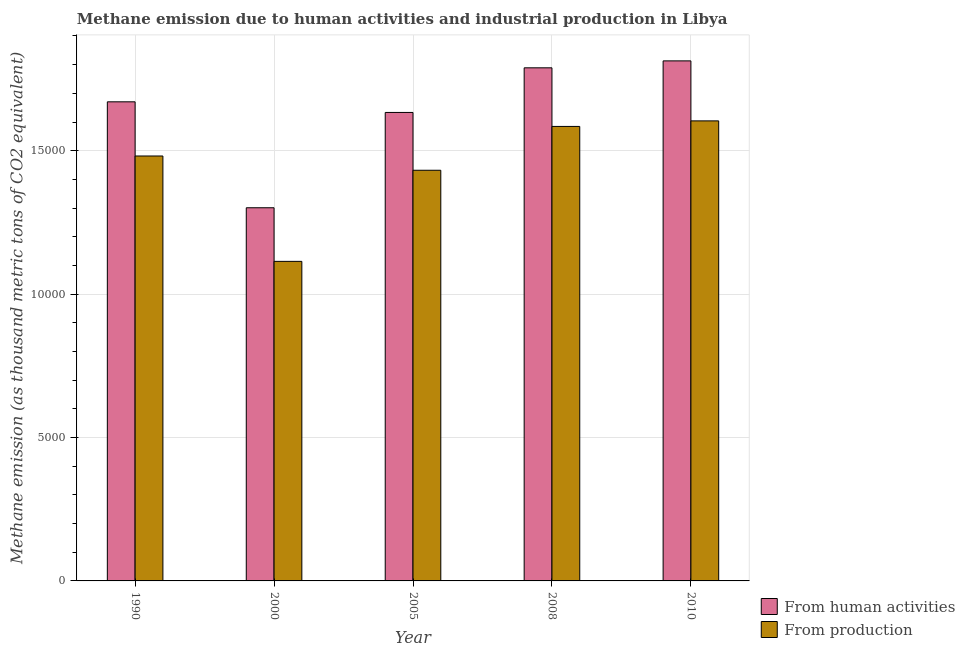Are the number of bars per tick equal to the number of legend labels?
Provide a short and direct response. Yes. How many bars are there on the 5th tick from the left?
Provide a succinct answer. 2. In how many cases, is the number of bars for a given year not equal to the number of legend labels?
Provide a succinct answer. 0. What is the amount of emissions generated from industries in 2005?
Your response must be concise. 1.43e+04. Across all years, what is the maximum amount of emissions generated from industries?
Your answer should be compact. 1.60e+04. Across all years, what is the minimum amount of emissions from human activities?
Offer a very short reply. 1.30e+04. What is the total amount of emissions from human activities in the graph?
Your answer should be compact. 8.21e+04. What is the difference between the amount of emissions generated from industries in 2005 and that in 2008?
Your answer should be compact. -1527.9. What is the difference between the amount of emissions generated from industries in 1990 and the amount of emissions from human activities in 2005?
Your answer should be compact. 497.1. What is the average amount of emissions generated from industries per year?
Offer a terse response. 1.44e+04. What is the ratio of the amount of emissions generated from industries in 2000 to that in 2008?
Provide a succinct answer. 0.7. Is the amount of emissions generated from industries in 1990 less than that in 2010?
Ensure brevity in your answer.  Yes. What is the difference between the highest and the second highest amount of emissions from human activities?
Offer a very short reply. 242.2. What is the difference between the highest and the lowest amount of emissions from human activities?
Ensure brevity in your answer.  5121.1. Is the sum of the amount of emissions from human activities in 2000 and 2008 greater than the maximum amount of emissions generated from industries across all years?
Keep it short and to the point. Yes. What does the 1st bar from the left in 2005 represents?
Your answer should be compact. From human activities. What does the 1st bar from the right in 2010 represents?
Offer a very short reply. From production. Does the graph contain any zero values?
Your answer should be very brief. No. Does the graph contain grids?
Provide a succinct answer. Yes. Where does the legend appear in the graph?
Keep it short and to the point. Bottom right. What is the title of the graph?
Make the answer very short. Methane emission due to human activities and industrial production in Libya. What is the label or title of the X-axis?
Your response must be concise. Year. What is the label or title of the Y-axis?
Make the answer very short. Methane emission (as thousand metric tons of CO2 equivalent). What is the Methane emission (as thousand metric tons of CO2 equivalent) of From human activities in 1990?
Your answer should be very brief. 1.67e+04. What is the Methane emission (as thousand metric tons of CO2 equivalent) in From production in 1990?
Give a very brief answer. 1.48e+04. What is the Methane emission (as thousand metric tons of CO2 equivalent) in From human activities in 2000?
Your answer should be compact. 1.30e+04. What is the Methane emission (as thousand metric tons of CO2 equivalent) in From production in 2000?
Offer a terse response. 1.11e+04. What is the Methane emission (as thousand metric tons of CO2 equivalent) in From human activities in 2005?
Offer a terse response. 1.63e+04. What is the Methane emission (as thousand metric tons of CO2 equivalent) of From production in 2005?
Offer a very short reply. 1.43e+04. What is the Methane emission (as thousand metric tons of CO2 equivalent) in From human activities in 2008?
Your response must be concise. 1.79e+04. What is the Methane emission (as thousand metric tons of CO2 equivalent) in From production in 2008?
Offer a terse response. 1.58e+04. What is the Methane emission (as thousand metric tons of CO2 equivalent) of From human activities in 2010?
Provide a short and direct response. 1.81e+04. What is the Methane emission (as thousand metric tons of CO2 equivalent) of From production in 2010?
Give a very brief answer. 1.60e+04. Across all years, what is the maximum Methane emission (as thousand metric tons of CO2 equivalent) of From human activities?
Make the answer very short. 1.81e+04. Across all years, what is the maximum Methane emission (as thousand metric tons of CO2 equivalent) of From production?
Your answer should be very brief. 1.60e+04. Across all years, what is the minimum Methane emission (as thousand metric tons of CO2 equivalent) in From human activities?
Offer a terse response. 1.30e+04. Across all years, what is the minimum Methane emission (as thousand metric tons of CO2 equivalent) of From production?
Your answer should be compact. 1.11e+04. What is the total Methane emission (as thousand metric tons of CO2 equivalent) in From human activities in the graph?
Give a very brief answer. 8.21e+04. What is the total Methane emission (as thousand metric tons of CO2 equivalent) of From production in the graph?
Provide a short and direct response. 7.22e+04. What is the difference between the Methane emission (as thousand metric tons of CO2 equivalent) in From human activities in 1990 and that in 2000?
Your answer should be compact. 3693.3. What is the difference between the Methane emission (as thousand metric tons of CO2 equivalent) in From production in 1990 and that in 2000?
Your answer should be very brief. 3673.7. What is the difference between the Methane emission (as thousand metric tons of CO2 equivalent) of From human activities in 1990 and that in 2005?
Your answer should be very brief. 370.1. What is the difference between the Methane emission (as thousand metric tons of CO2 equivalent) in From production in 1990 and that in 2005?
Keep it short and to the point. 497.1. What is the difference between the Methane emission (as thousand metric tons of CO2 equivalent) in From human activities in 1990 and that in 2008?
Your response must be concise. -1185.6. What is the difference between the Methane emission (as thousand metric tons of CO2 equivalent) in From production in 1990 and that in 2008?
Make the answer very short. -1030.8. What is the difference between the Methane emission (as thousand metric tons of CO2 equivalent) of From human activities in 1990 and that in 2010?
Offer a terse response. -1427.8. What is the difference between the Methane emission (as thousand metric tons of CO2 equivalent) of From production in 1990 and that in 2010?
Offer a very short reply. -1224.2. What is the difference between the Methane emission (as thousand metric tons of CO2 equivalent) of From human activities in 2000 and that in 2005?
Offer a very short reply. -3323.2. What is the difference between the Methane emission (as thousand metric tons of CO2 equivalent) in From production in 2000 and that in 2005?
Offer a very short reply. -3176.6. What is the difference between the Methane emission (as thousand metric tons of CO2 equivalent) in From human activities in 2000 and that in 2008?
Make the answer very short. -4878.9. What is the difference between the Methane emission (as thousand metric tons of CO2 equivalent) of From production in 2000 and that in 2008?
Offer a very short reply. -4704.5. What is the difference between the Methane emission (as thousand metric tons of CO2 equivalent) in From human activities in 2000 and that in 2010?
Keep it short and to the point. -5121.1. What is the difference between the Methane emission (as thousand metric tons of CO2 equivalent) in From production in 2000 and that in 2010?
Offer a very short reply. -4897.9. What is the difference between the Methane emission (as thousand metric tons of CO2 equivalent) in From human activities in 2005 and that in 2008?
Your response must be concise. -1555.7. What is the difference between the Methane emission (as thousand metric tons of CO2 equivalent) of From production in 2005 and that in 2008?
Provide a succinct answer. -1527.9. What is the difference between the Methane emission (as thousand metric tons of CO2 equivalent) in From human activities in 2005 and that in 2010?
Offer a very short reply. -1797.9. What is the difference between the Methane emission (as thousand metric tons of CO2 equivalent) of From production in 2005 and that in 2010?
Provide a succinct answer. -1721.3. What is the difference between the Methane emission (as thousand metric tons of CO2 equivalent) in From human activities in 2008 and that in 2010?
Give a very brief answer. -242.2. What is the difference between the Methane emission (as thousand metric tons of CO2 equivalent) of From production in 2008 and that in 2010?
Provide a short and direct response. -193.4. What is the difference between the Methane emission (as thousand metric tons of CO2 equivalent) in From human activities in 1990 and the Methane emission (as thousand metric tons of CO2 equivalent) in From production in 2000?
Your answer should be very brief. 5562.4. What is the difference between the Methane emission (as thousand metric tons of CO2 equivalent) of From human activities in 1990 and the Methane emission (as thousand metric tons of CO2 equivalent) of From production in 2005?
Keep it short and to the point. 2385.8. What is the difference between the Methane emission (as thousand metric tons of CO2 equivalent) of From human activities in 1990 and the Methane emission (as thousand metric tons of CO2 equivalent) of From production in 2008?
Keep it short and to the point. 857.9. What is the difference between the Methane emission (as thousand metric tons of CO2 equivalent) in From human activities in 1990 and the Methane emission (as thousand metric tons of CO2 equivalent) in From production in 2010?
Ensure brevity in your answer.  664.5. What is the difference between the Methane emission (as thousand metric tons of CO2 equivalent) in From human activities in 2000 and the Methane emission (as thousand metric tons of CO2 equivalent) in From production in 2005?
Your answer should be compact. -1307.5. What is the difference between the Methane emission (as thousand metric tons of CO2 equivalent) in From human activities in 2000 and the Methane emission (as thousand metric tons of CO2 equivalent) in From production in 2008?
Keep it short and to the point. -2835.4. What is the difference between the Methane emission (as thousand metric tons of CO2 equivalent) of From human activities in 2000 and the Methane emission (as thousand metric tons of CO2 equivalent) of From production in 2010?
Offer a terse response. -3028.8. What is the difference between the Methane emission (as thousand metric tons of CO2 equivalent) in From human activities in 2005 and the Methane emission (as thousand metric tons of CO2 equivalent) in From production in 2008?
Make the answer very short. 487.8. What is the difference between the Methane emission (as thousand metric tons of CO2 equivalent) in From human activities in 2005 and the Methane emission (as thousand metric tons of CO2 equivalent) in From production in 2010?
Give a very brief answer. 294.4. What is the difference between the Methane emission (as thousand metric tons of CO2 equivalent) of From human activities in 2008 and the Methane emission (as thousand metric tons of CO2 equivalent) of From production in 2010?
Offer a very short reply. 1850.1. What is the average Methane emission (as thousand metric tons of CO2 equivalent) of From human activities per year?
Offer a terse response. 1.64e+04. What is the average Methane emission (as thousand metric tons of CO2 equivalent) in From production per year?
Give a very brief answer. 1.44e+04. In the year 1990, what is the difference between the Methane emission (as thousand metric tons of CO2 equivalent) of From human activities and Methane emission (as thousand metric tons of CO2 equivalent) of From production?
Provide a succinct answer. 1888.7. In the year 2000, what is the difference between the Methane emission (as thousand metric tons of CO2 equivalent) of From human activities and Methane emission (as thousand metric tons of CO2 equivalent) of From production?
Ensure brevity in your answer.  1869.1. In the year 2005, what is the difference between the Methane emission (as thousand metric tons of CO2 equivalent) of From human activities and Methane emission (as thousand metric tons of CO2 equivalent) of From production?
Keep it short and to the point. 2015.7. In the year 2008, what is the difference between the Methane emission (as thousand metric tons of CO2 equivalent) of From human activities and Methane emission (as thousand metric tons of CO2 equivalent) of From production?
Your answer should be compact. 2043.5. In the year 2010, what is the difference between the Methane emission (as thousand metric tons of CO2 equivalent) of From human activities and Methane emission (as thousand metric tons of CO2 equivalent) of From production?
Your answer should be very brief. 2092.3. What is the ratio of the Methane emission (as thousand metric tons of CO2 equivalent) in From human activities in 1990 to that in 2000?
Your response must be concise. 1.28. What is the ratio of the Methane emission (as thousand metric tons of CO2 equivalent) in From production in 1990 to that in 2000?
Ensure brevity in your answer.  1.33. What is the ratio of the Methane emission (as thousand metric tons of CO2 equivalent) in From human activities in 1990 to that in 2005?
Your response must be concise. 1.02. What is the ratio of the Methane emission (as thousand metric tons of CO2 equivalent) of From production in 1990 to that in 2005?
Your answer should be compact. 1.03. What is the ratio of the Methane emission (as thousand metric tons of CO2 equivalent) in From human activities in 1990 to that in 2008?
Offer a very short reply. 0.93. What is the ratio of the Methane emission (as thousand metric tons of CO2 equivalent) of From production in 1990 to that in 2008?
Make the answer very short. 0.94. What is the ratio of the Methane emission (as thousand metric tons of CO2 equivalent) of From human activities in 1990 to that in 2010?
Your response must be concise. 0.92. What is the ratio of the Methane emission (as thousand metric tons of CO2 equivalent) in From production in 1990 to that in 2010?
Provide a short and direct response. 0.92. What is the ratio of the Methane emission (as thousand metric tons of CO2 equivalent) of From human activities in 2000 to that in 2005?
Your answer should be very brief. 0.8. What is the ratio of the Methane emission (as thousand metric tons of CO2 equivalent) in From production in 2000 to that in 2005?
Offer a terse response. 0.78. What is the ratio of the Methane emission (as thousand metric tons of CO2 equivalent) of From human activities in 2000 to that in 2008?
Ensure brevity in your answer.  0.73. What is the ratio of the Methane emission (as thousand metric tons of CO2 equivalent) of From production in 2000 to that in 2008?
Keep it short and to the point. 0.7. What is the ratio of the Methane emission (as thousand metric tons of CO2 equivalent) of From human activities in 2000 to that in 2010?
Keep it short and to the point. 0.72. What is the ratio of the Methane emission (as thousand metric tons of CO2 equivalent) of From production in 2000 to that in 2010?
Ensure brevity in your answer.  0.69. What is the ratio of the Methane emission (as thousand metric tons of CO2 equivalent) in From production in 2005 to that in 2008?
Your answer should be compact. 0.9. What is the ratio of the Methane emission (as thousand metric tons of CO2 equivalent) in From human activities in 2005 to that in 2010?
Make the answer very short. 0.9. What is the ratio of the Methane emission (as thousand metric tons of CO2 equivalent) of From production in 2005 to that in 2010?
Ensure brevity in your answer.  0.89. What is the ratio of the Methane emission (as thousand metric tons of CO2 equivalent) of From human activities in 2008 to that in 2010?
Provide a succinct answer. 0.99. What is the ratio of the Methane emission (as thousand metric tons of CO2 equivalent) of From production in 2008 to that in 2010?
Offer a terse response. 0.99. What is the difference between the highest and the second highest Methane emission (as thousand metric tons of CO2 equivalent) in From human activities?
Offer a very short reply. 242.2. What is the difference between the highest and the second highest Methane emission (as thousand metric tons of CO2 equivalent) in From production?
Your answer should be very brief. 193.4. What is the difference between the highest and the lowest Methane emission (as thousand metric tons of CO2 equivalent) of From human activities?
Offer a very short reply. 5121.1. What is the difference between the highest and the lowest Methane emission (as thousand metric tons of CO2 equivalent) of From production?
Provide a short and direct response. 4897.9. 